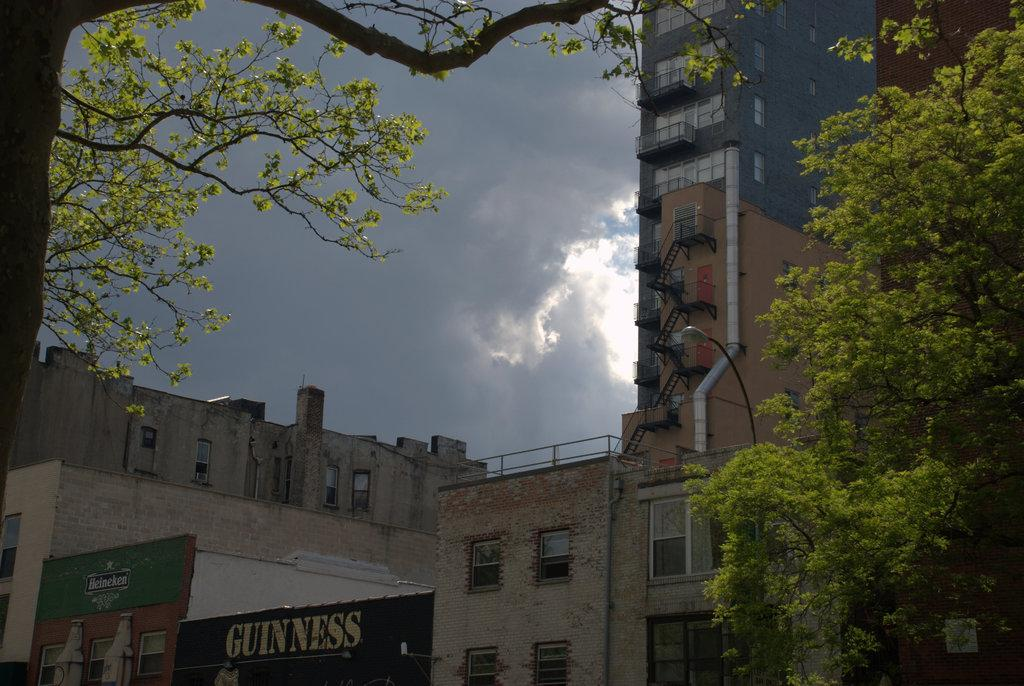What type of vegetation is present in the image? There are trees in the image. What is the color of the trees in the image? The trees are green. What can be seen in the background of the image? There are buildings in the background of the image. What colors are the buildings in the image? The buildings are in brown and gray colors. What is visible above the trees and buildings in the image? The sky is visible in the image. What colors are the sky in the image? The sky is in white and gray colors. Who is the owner of the wheel in the image? There is no wheel present in the image, so it is not possible to determine the owner. Is there any rain visible in the image? There is no rain visible in the image; the sky is in white and gray colors, but it does not indicate rain. 